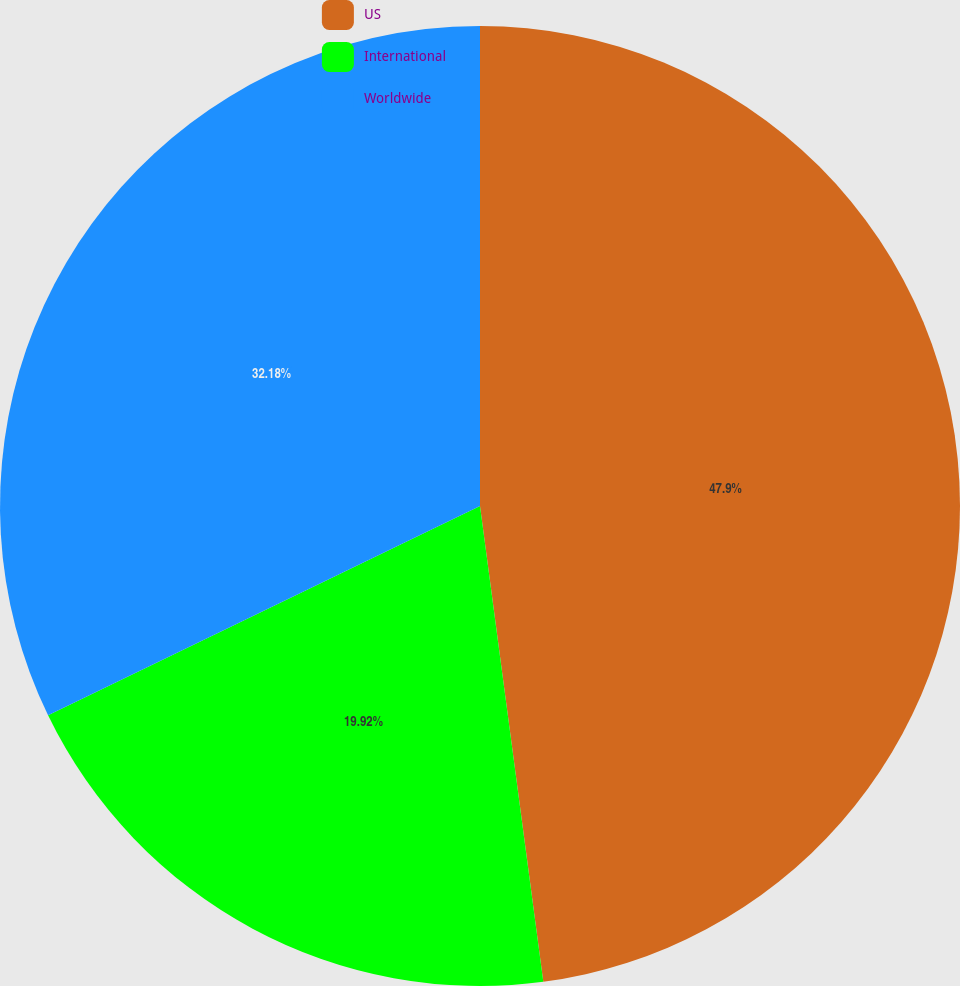Convert chart to OTSL. <chart><loc_0><loc_0><loc_500><loc_500><pie_chart><fcel>US<fcel>International<fcel>Worldwide<nl><fcel>47.89%<fcel>19.92%<fcel>32.18%<nl></chart> 